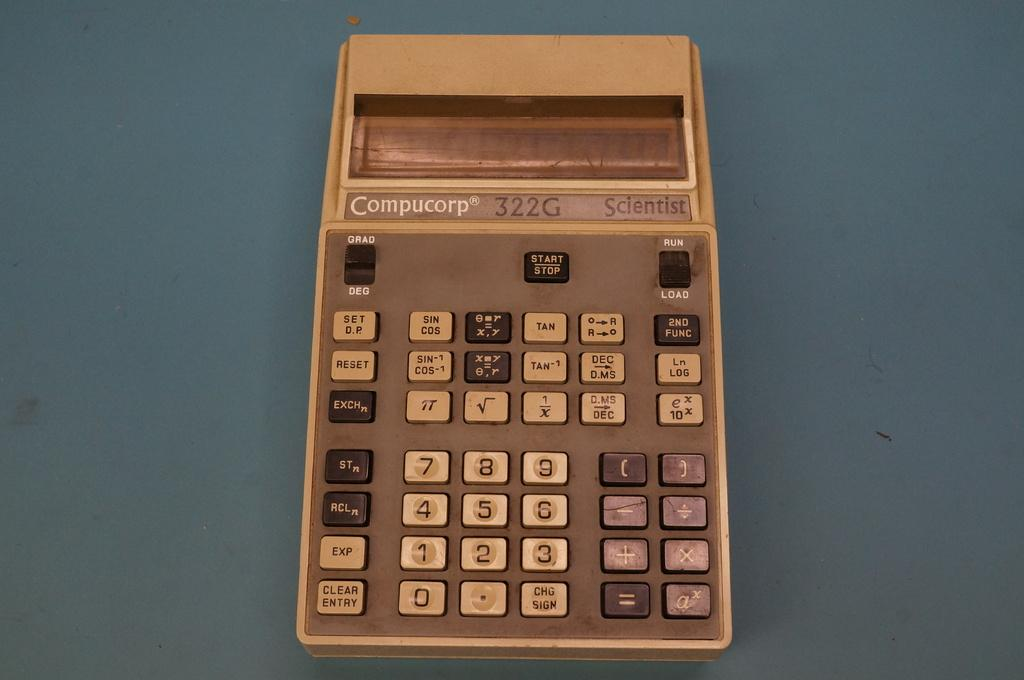<image>
Give a short and clear explanation of the subsequent image. Compucorp calculator with white, black, and purple buttons on a grey surface. 